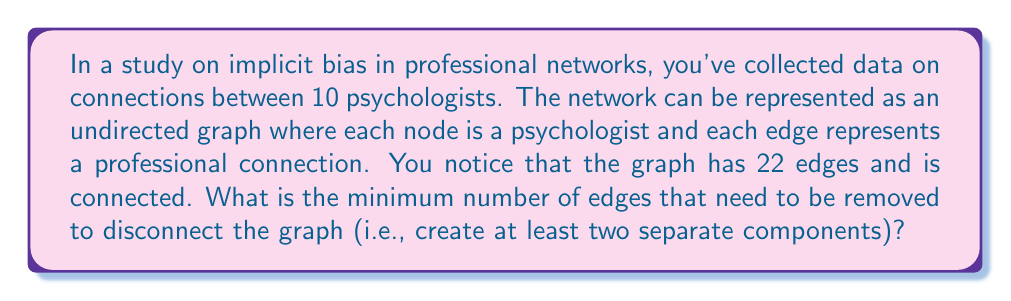Give your solution to this math problem. To solve this problem, we need to understand the concept of edge connectivity in graph theory. The edge connectivity of a graph is the minimum number of edges that need to be removed to disconnect the graph.

Let's approach this step-by-step:

1) First, recall that for any connected graph $G$ with $n$ vertices, the minimum number of edges required to keep it connected is $n-1$. This forms a spanning tree of the graph.

2) In our case, we have $n = 10$ vertices (psychologists) and 22 edges.

3) The number of extra edges beyond the minimum required for connectivity is:
   $22 - (10-1) = 22 - 9 = 13$

4) These 13 extra edges provide redundant connections in the network.

5) The edge connectivity of a graph is always less than or equal to the minimum degree of any vertex in the graph. However, without more information about the specific structure of the graph, we can't determine the exact minimum degree.

6) What we do know is that to disconnect the graph, we need to remove enough edges to isolate at least one vertex or group of vertices from the rest.

7) In the worst case scenario (in terms of connectivity), these 13 extra edges could be distributed to connect one vertex to all other vertices. In this case, we would need to remove all 13 extra edges plus 1 more to disconnect the graph.

8) Therefore, the minimum number of edges that need to be removed to disconnect the graph is at most 14.

9) However, it could be less than 14 if the extra edges are not optimally distributed for connectivity. The actual minimum could be as low as 1 if there's a bridge in the graph.

10) Without more information about the specific structure of the graph, we can conclude that the edge connectivity is at least 1 and at most 14.

This analysis demonstrates how graph theory can be applied to understand the robustness of social networks, which is relevant to studying how implicit biases might spread or be reinforced through professional connections.
Answer: The minimum number of edges that need to be removed to disconnect the graph is at least 1 and at most 14, depending on the specific structure of the graph. 